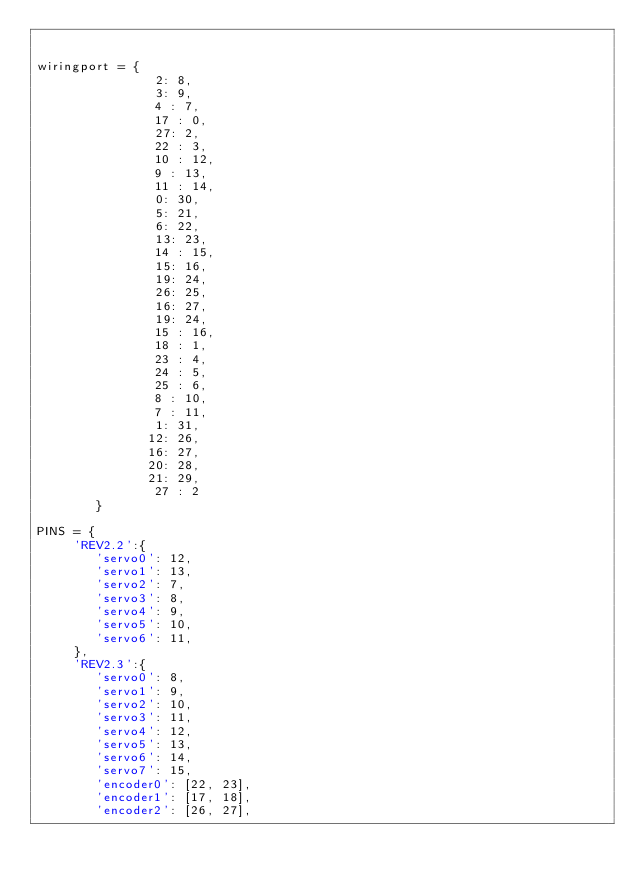<code> <loc_0><loc_0><loc_500><loc_500><_Python_>

wiringport = {
                2: 8,
                3: 9,
                4 : 7,
                17 : 0,
                27: 2,
                22 : 3,
                10 : 12,
                9 : 13,
                11 : 14,
                0: 30,
                5: 21, 
                6: 22,
                13: 23,
                14 : 15,
                15: 16,
                19: 24,
                26: 25,
                16: 27,
                19: 24,
                15 : 16,
                18 : 1,
                23 : 4,
                24 : 5,
                25 : 6, 
                8 : 10,
                7 : 11,
                1: 31,
               12: 26,
               16: 27,
               20: 28,
               21: 29,
                27 : 2
        }

PINS = {
     'REV2.2':{
        'servo0': 12,
        'servo1': 13,
        'servo2': 7,
        'servo3': 8,
        'servo4': 9,
        'servo5': 10,
        'servo6': 11,
     },
     'REV2.3':{
        'servo0': 8,
        'servo1': 9,
        'servo2': 10,
        'servo3': 11,
        'servo4': 12,
        'servo5': 13,
        'servo6': 14,
        'servo7': 15,
        'encoder0': [22, 23],
        'encoder1': [17, 18],
        'encoder2': [26, 27],</code> 